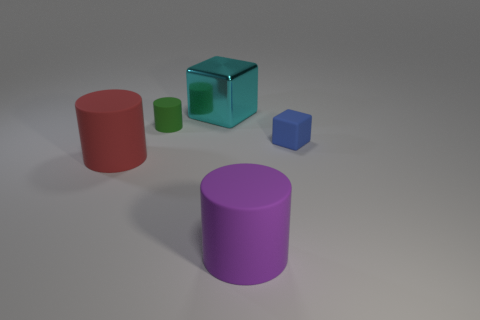There is a tiny thing that is the same shape as the big shiny object; what color is it?
Your answer should be compact. Blue. There is a large thing that is in front of the small green cylinder and behind the large purple cylinder; what is its material?
Make the answer very short. Rubber. There is a cylinder in front of the red rubber cylinder; is its size the same as the large cyan block?
Your answer should be very brief. Yes. What material is the green object?
Keep it short and to the point. Rubber. What color is the big matte object right of the green rubber object?
Give a very brief answer. Purple. How many tiny objects are purple cylinders or matte things?
Your answer should be compact. 2. What number of other objects are the same color as the tiny cylinder?
Your response must be concise. 0. How many red things are large blocks or large objects?
Your answer should be compact. 1. There is a big metallic object; is its shape the same as the big purple thing that is right of the large red rubber cylinder?
Offer a terse response. No. The small blue matte thing has what shape?
Offer a terse response. Cube. 